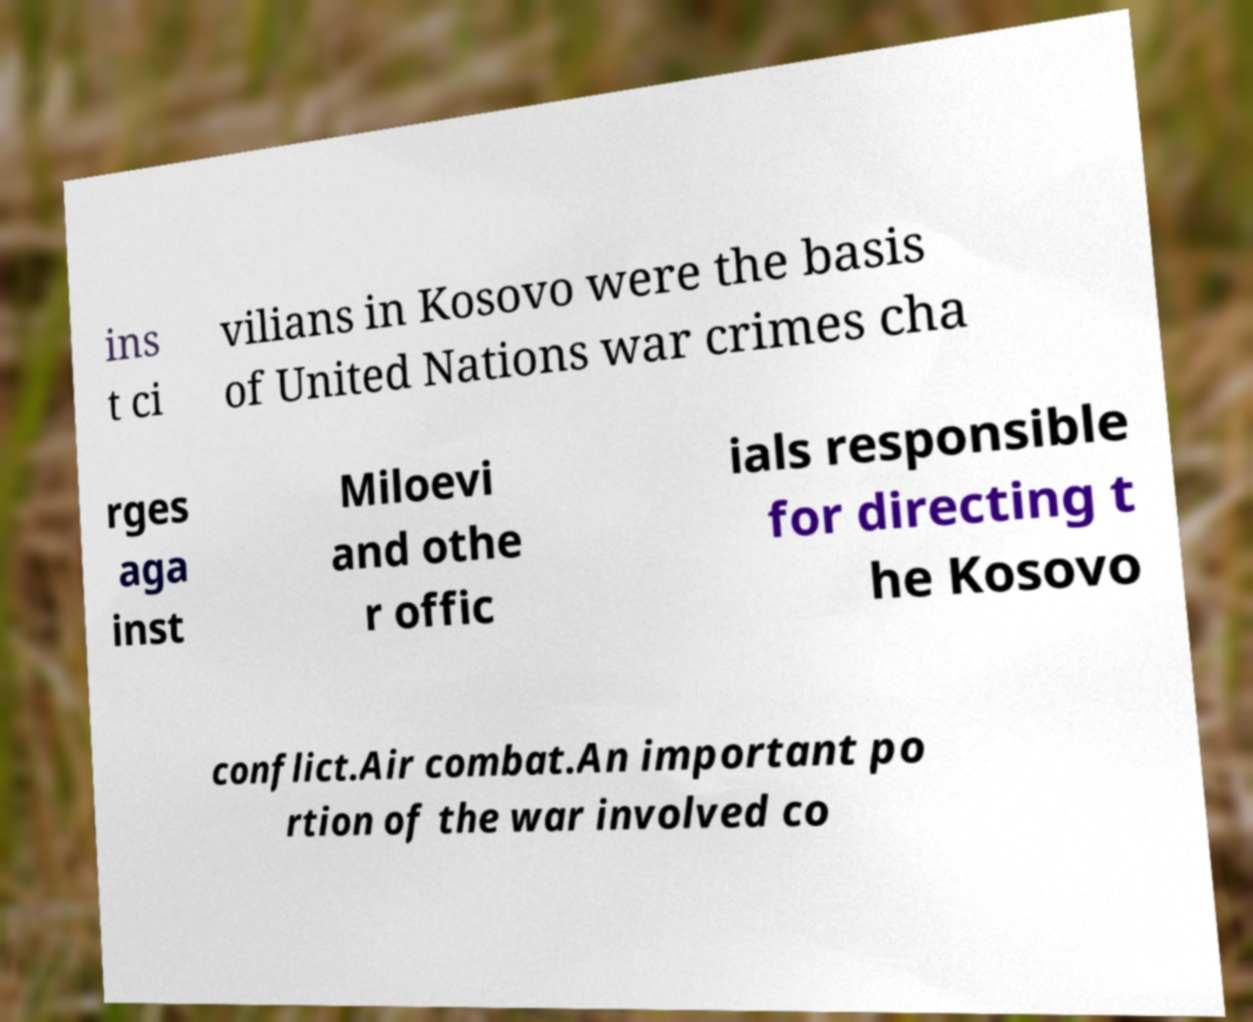Can you accurately transcribe the text from the provided image for me? ins t ci vilians in Kosovo were the basis of United Nations war crimes cha rges aga inst Miloevi and othe r offic ials responsible for directing t he Kosovo conflict.Air combat.An important po rtion of the war involved co 